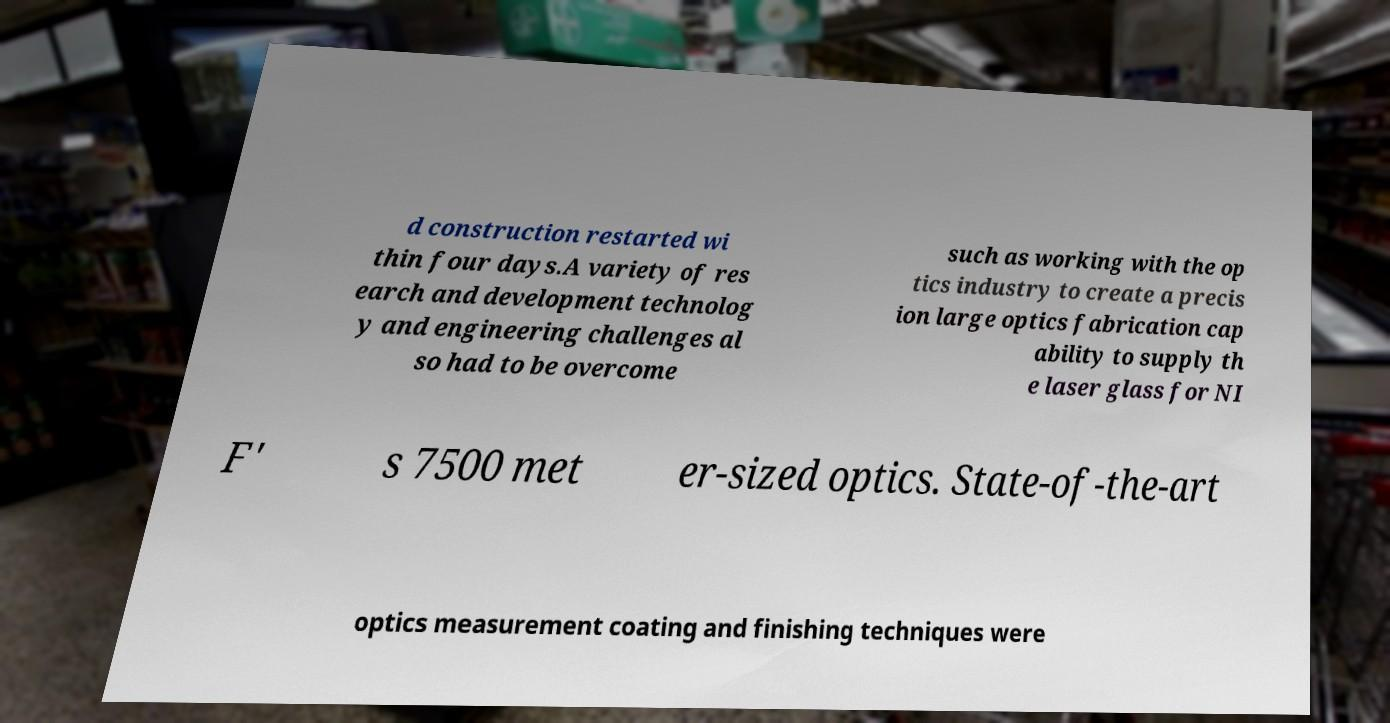What messages or text are displayed in this image? I need them in a readable, typed format. d construction restarted wi thin four days.A variety of res earch and development technolog y and engineering challenges al so had to be overcome such as working with the op tics industry to create a precis ion large optics fabrication cap ability to supply th e laser glass for NI F' s 7500 met er-sized optics. State-of-the-art optics measurement coating and finishing techniques were 